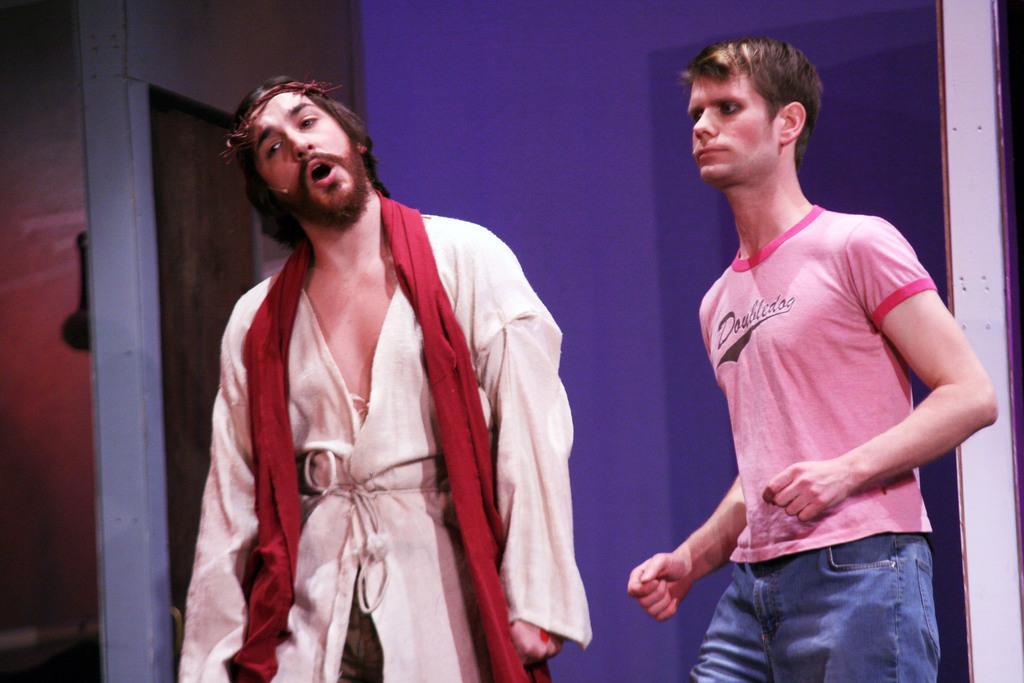Describe this image in one or two sentences. In the middle of the image two persons are standing and doing something. Behind them there is wall. 